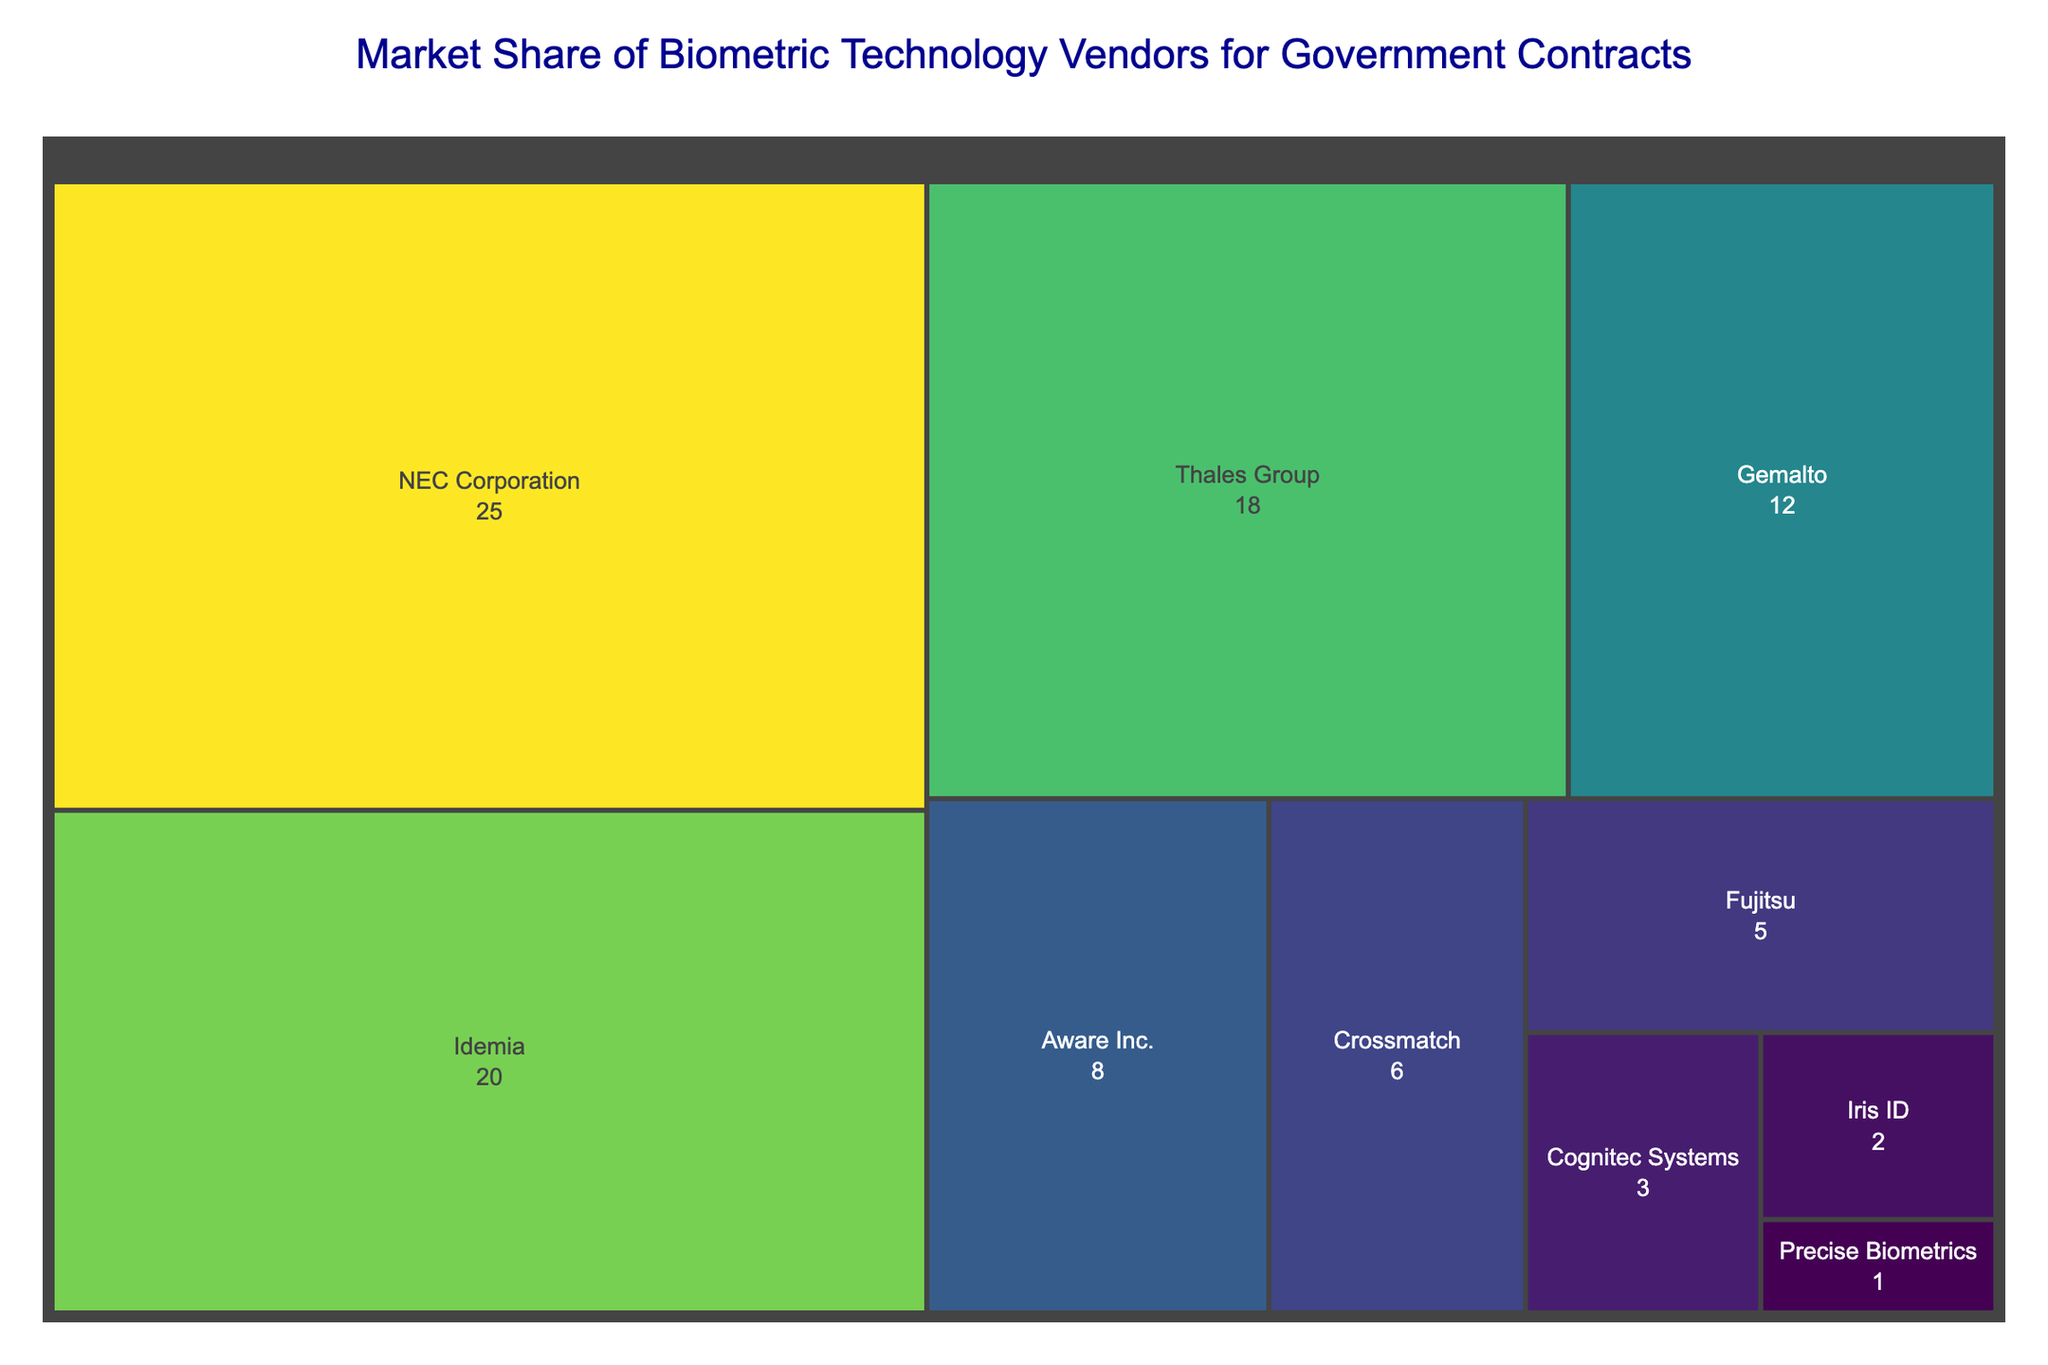What is the title of the treemap? The title of the treemap is displayed at the top in a larger and different colored font compared to the rest of the text in the plot. It is written as "Market Share of Biometric Technology Vendors for Government Contracts."
Answer: Market Share of Biometric Technology Vendors for Government Contracts Which company has the largest market share? The size of each section in the treemap represents the market share of each company. The largest section is labeled "NEC Corporation."
Answer: NEC Corporation How much market share does Thales Group have? Each section in the treemap is labeled with both the company name and its market share percentage. The section labeled "Thales Group" shows "18%."
Answer: 18% What is the combined market share of Gemalto and Aware Inc.? The market share percentages for Gemalto and Aware Inc. are 12% and 8% respectively. Adding these gives: 12 + 8 = 20%.
Answer: 20% Which company has a lower market share, Crossmatch or Fujitsu? By comparing the sizes and labels of the sections in the treemap, Crossmatch has a 6% market share while Fujitsu has a 5% market share.
Answer: Fujitsu What's the difference in market share between Idemia and Precise Biometrics? Idemia has a 20% market share and Precise Biometrics has a 1% market share. The difference is 20 - 1 = 19%.
Answer: 19% If you add the market shares of Cognitec Systems, Iris ID, and Precise Biometrics, what percentage do you get? Cognitec Systems has 3%, Iris ID has 2%, and Precise Biometrics has 1%. Adding these gives: 3 + 2 + 1 = 6%.
Answer: 6% Which company has the second-largest market share? The section with the second-largest market share is labeled "Idemia," which has a 20% market share.
Answer: Idemia Is the market share of NEC Corporation greater than the combined market share of Fujitsu, Cognitec Systems, and Iris ID? NEC Corporation has a 25% market share. The combined market share of Fujitsu, Cognitec Systems, and Iris ID is 5% + 3% + 2% = 10%. Therefore, 25% is greater than 10%.
Answer: Yes What is the color gradient used in the treemap? The color gradient represents the market share percentage and ranges from darker to lighter shades. This is to visually differentiate the segments, where higher market shares get more intense shades and lower shares get lighter shades. The specific scale used is named "Viridis."
Answer: Viridis 